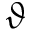Convert formula to latex. <formula><loc_0><loc_0><loc_500><loc_500>\vartheta</formula> 